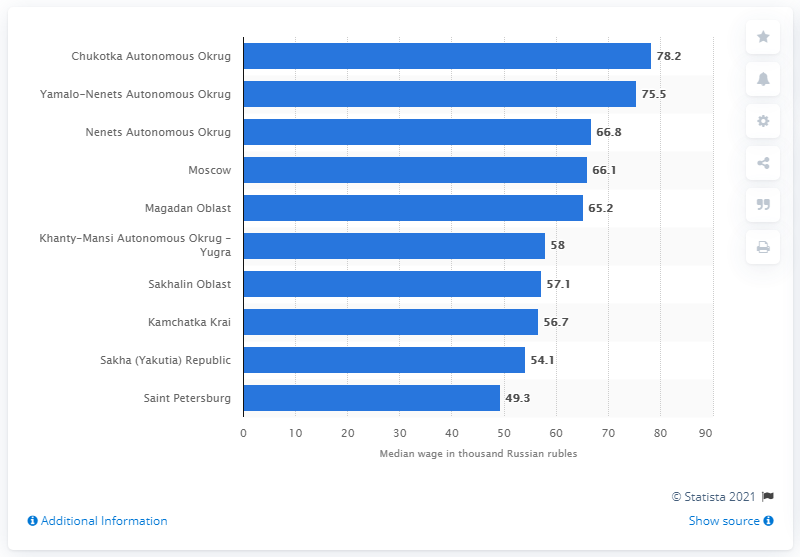Give some essential details in this illustration. According to data from September 2018 to August 2019, the Chukotka Autonomous Okrug had the highest median monthly salary among all federal subjects in the country. The second largest region in Russia is the Yamalo-Nenets Autonomous Okrug. 